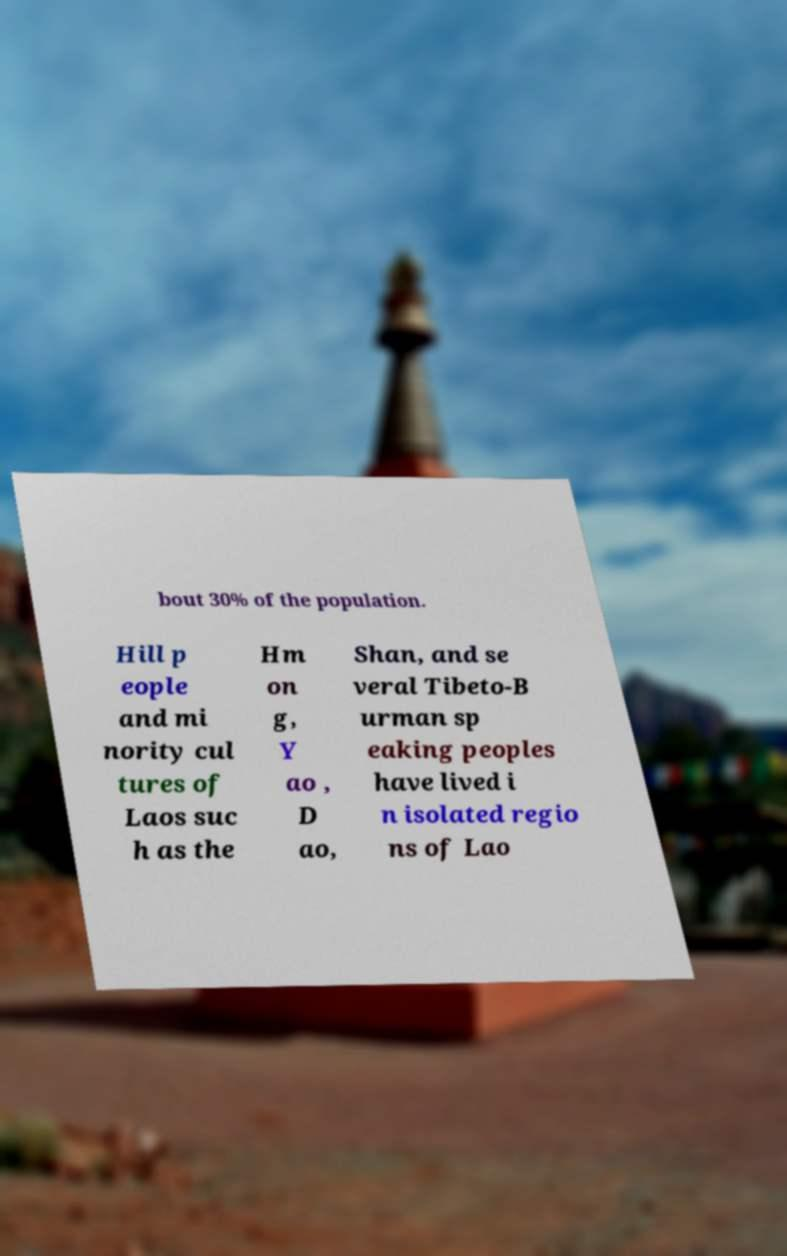Please read and relay the text visible in this image. What does it say? bout 30% of the population. Hill p eople and mi nority cul tures of Laos suc h as the Hm on g, Y ao , D ao, Shan, and se veral Tibeto-B urman sp eaking peoples have lived i n isolated regio ns of Lao 